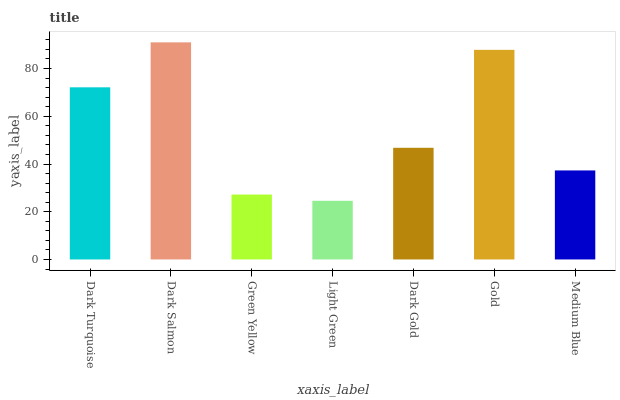Is Green Yellow the minimum?
Answer yes or no. No. Is Green Yellow the maximum?
Answer yes or no. No. Is Dark Salmon greater than Green Yellow?
Answer yes or no. Yes. Is Green Yellow less than Dark Salmon?
Answer yes or no. Yes. Is Green Yellow greater than Dark Salmon?
Answer yes or no. No. Is Dark Salmon less than Green Yellow?
Answer yes or no. No. Is Dark Gold the high median?
Answer yes or no. Yes. Is Dark Gold the low median?
Answer yes or no. Yes. Is Medium Blue the high median?
Answer yes or no. No. Is Dark Salmon the low median?
Answer yes or no. No. 